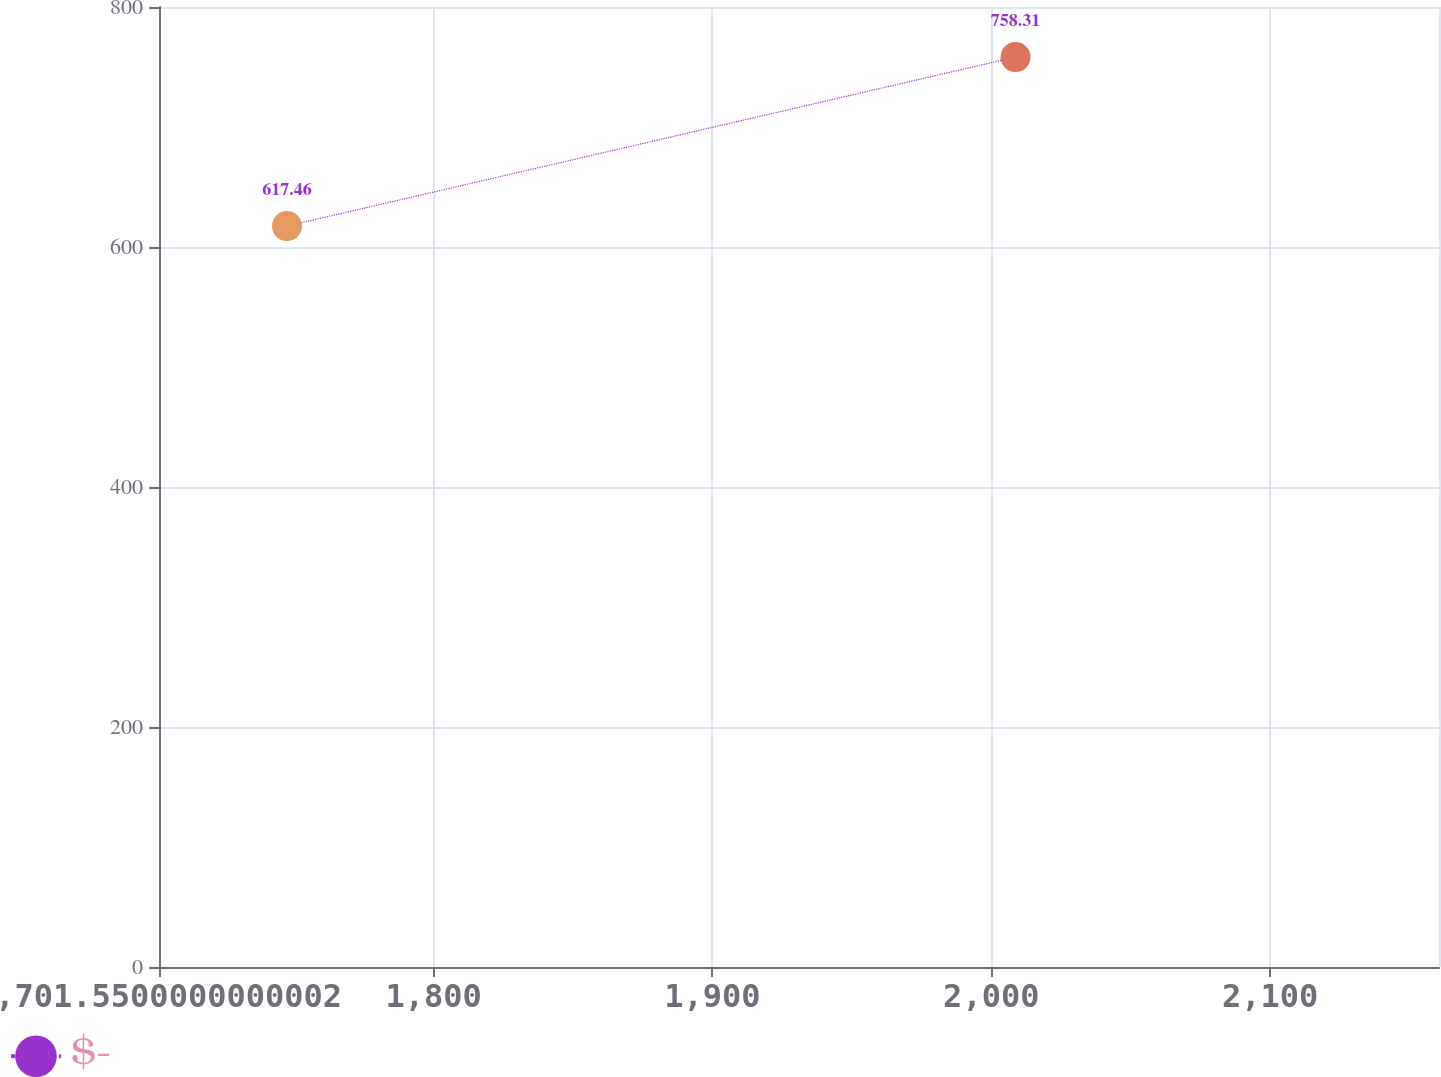Convert chart to OTSL. <chart><loc_0><loc_0><loc_500><loc_500><line_chart><ecel><fcel>$-<nl><fcel>1747.45<fcel>617.46<nl><fcel>2008.7<fcel>758.31<nl><fcel>2161.92<fcel>12.53<nl><fcel>2206.45<fcel>891.92<nl></chart> 